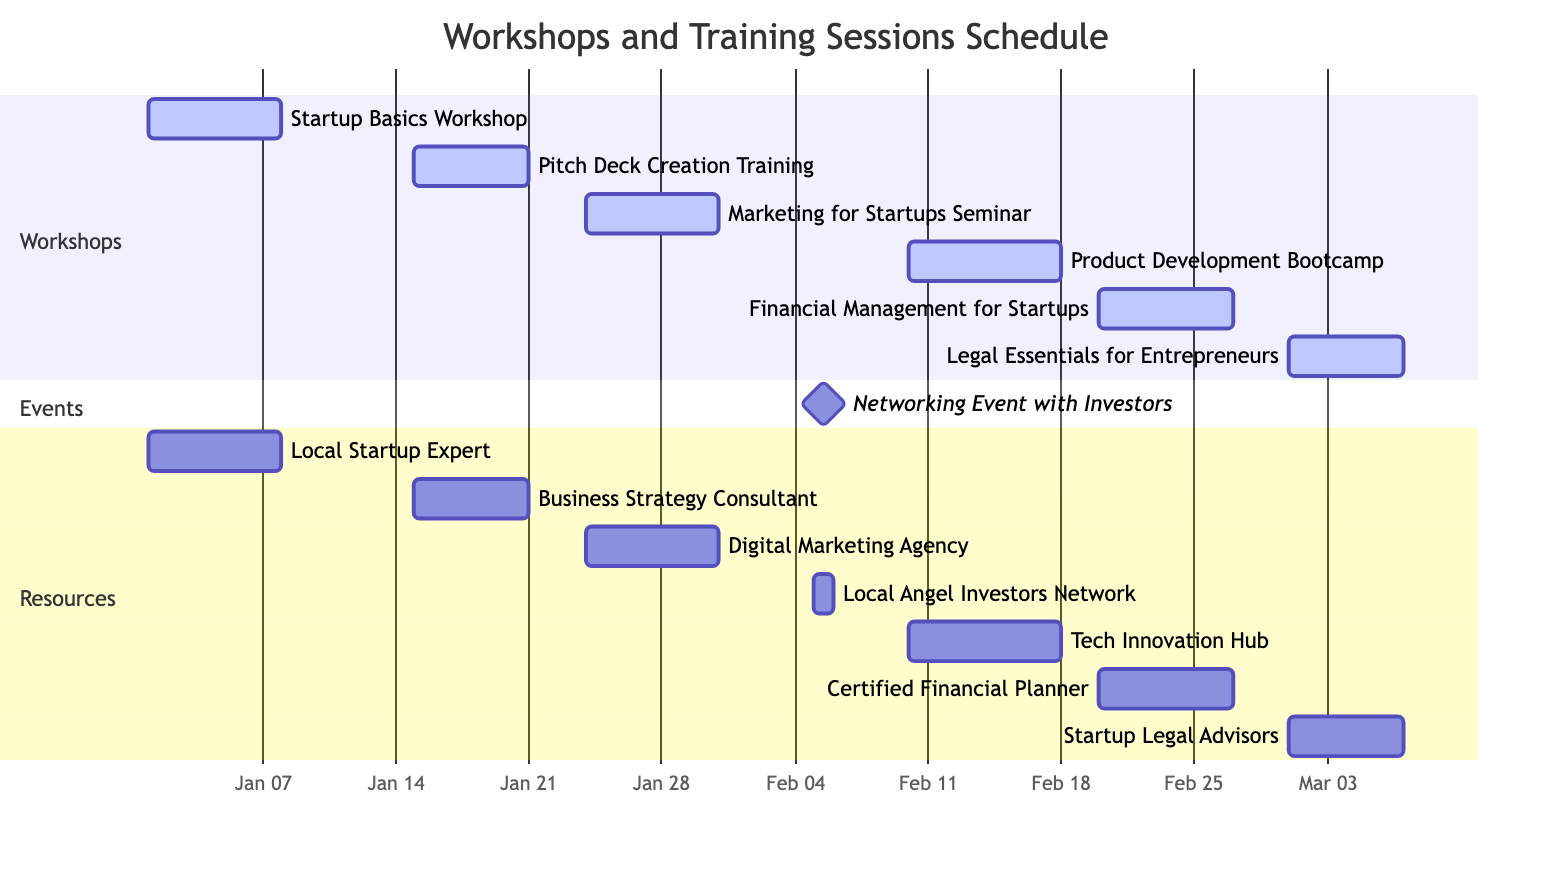What is the duration of the Startup Basics Workshop? The duration of the Startup Basics Workshop is given as 7 days. This information is directly stated in the diagram against the respective task.
Answer: 7 days How many seminars/workshops are scheduled for January? In January, there are three workshops: Startup Basics Workshop (January 1-7), Pitch Deck Creation Training (January 15-20), and Marketing for Startups Seminar (January 24-30). Counting these gives a total of three.
Answer: 3 Which workshop starts on February 10? The workshop that starts on February 10 is the Product Development Bootcamp. This can be identified by looking at the start dates in the diagram.
Answer: Product Development Bootcamp What is the end date of the Financial Management for Startups session? The Financial Management for Startups session has an end date of February 26. This is found by examining the end date listed next to the task in the diagram.
Answer: February 26 How many resources are assigned to the March workshops? In March, there is one workshop scheduled, which is Legal Essentials for Entrepreneurs, and it has one resource assigned, Startup Legal Advisors. Therefore, the count is one.
Answer: 1 Which task has the longest duration in total? The task with the longest duration is the Product Development Bootcamp, which lasts for 8 days. By comparing the durations of all tasks, this is the highest value.
Answer: 8 days What is the task immediately following the Networking Event with Investors? The task following the Networking Event with Investors is the Product Development Bootcamp, which starts on February 10, immediately after the networking event on February 5. This is determined by looking at the timeline and the subsequent tasks.
Answer: Product Development Bootcamp What is the total number of training sessions planned? There are six training sessions planned: Startup Basics Workshop, Pitch Deck Creation Training, Marketing for Startups Seminar, Product Development Bootcamp, Financial Management for Startups, and Legal Essentials for Entrepreneurs, totaling six. This is counted by listing each task.
Answer: 6 